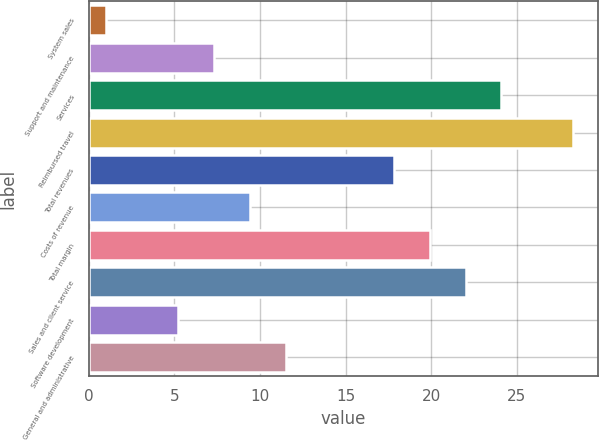Convert chart. <chart><loc_0><loc_0><loc_500><loc_500><bar_chart><fcel>System sales<fcel>Support and maintenance<fcel>Services<fcel>Reimbursed travel<fcel>Total revenues<fcel>Costs of revenue<fcel>Total margin<fcel>Sales and client service<fcel>Software development<fcel>General and administrative<nl><fcel>1<fcel>7.3<fcel>24.1<fcel>28.3<fcel>17.8<fcel>9.4<fcel>19.9<fcel>22<fcel>5.2<fcel>11.5<nl></chart> 